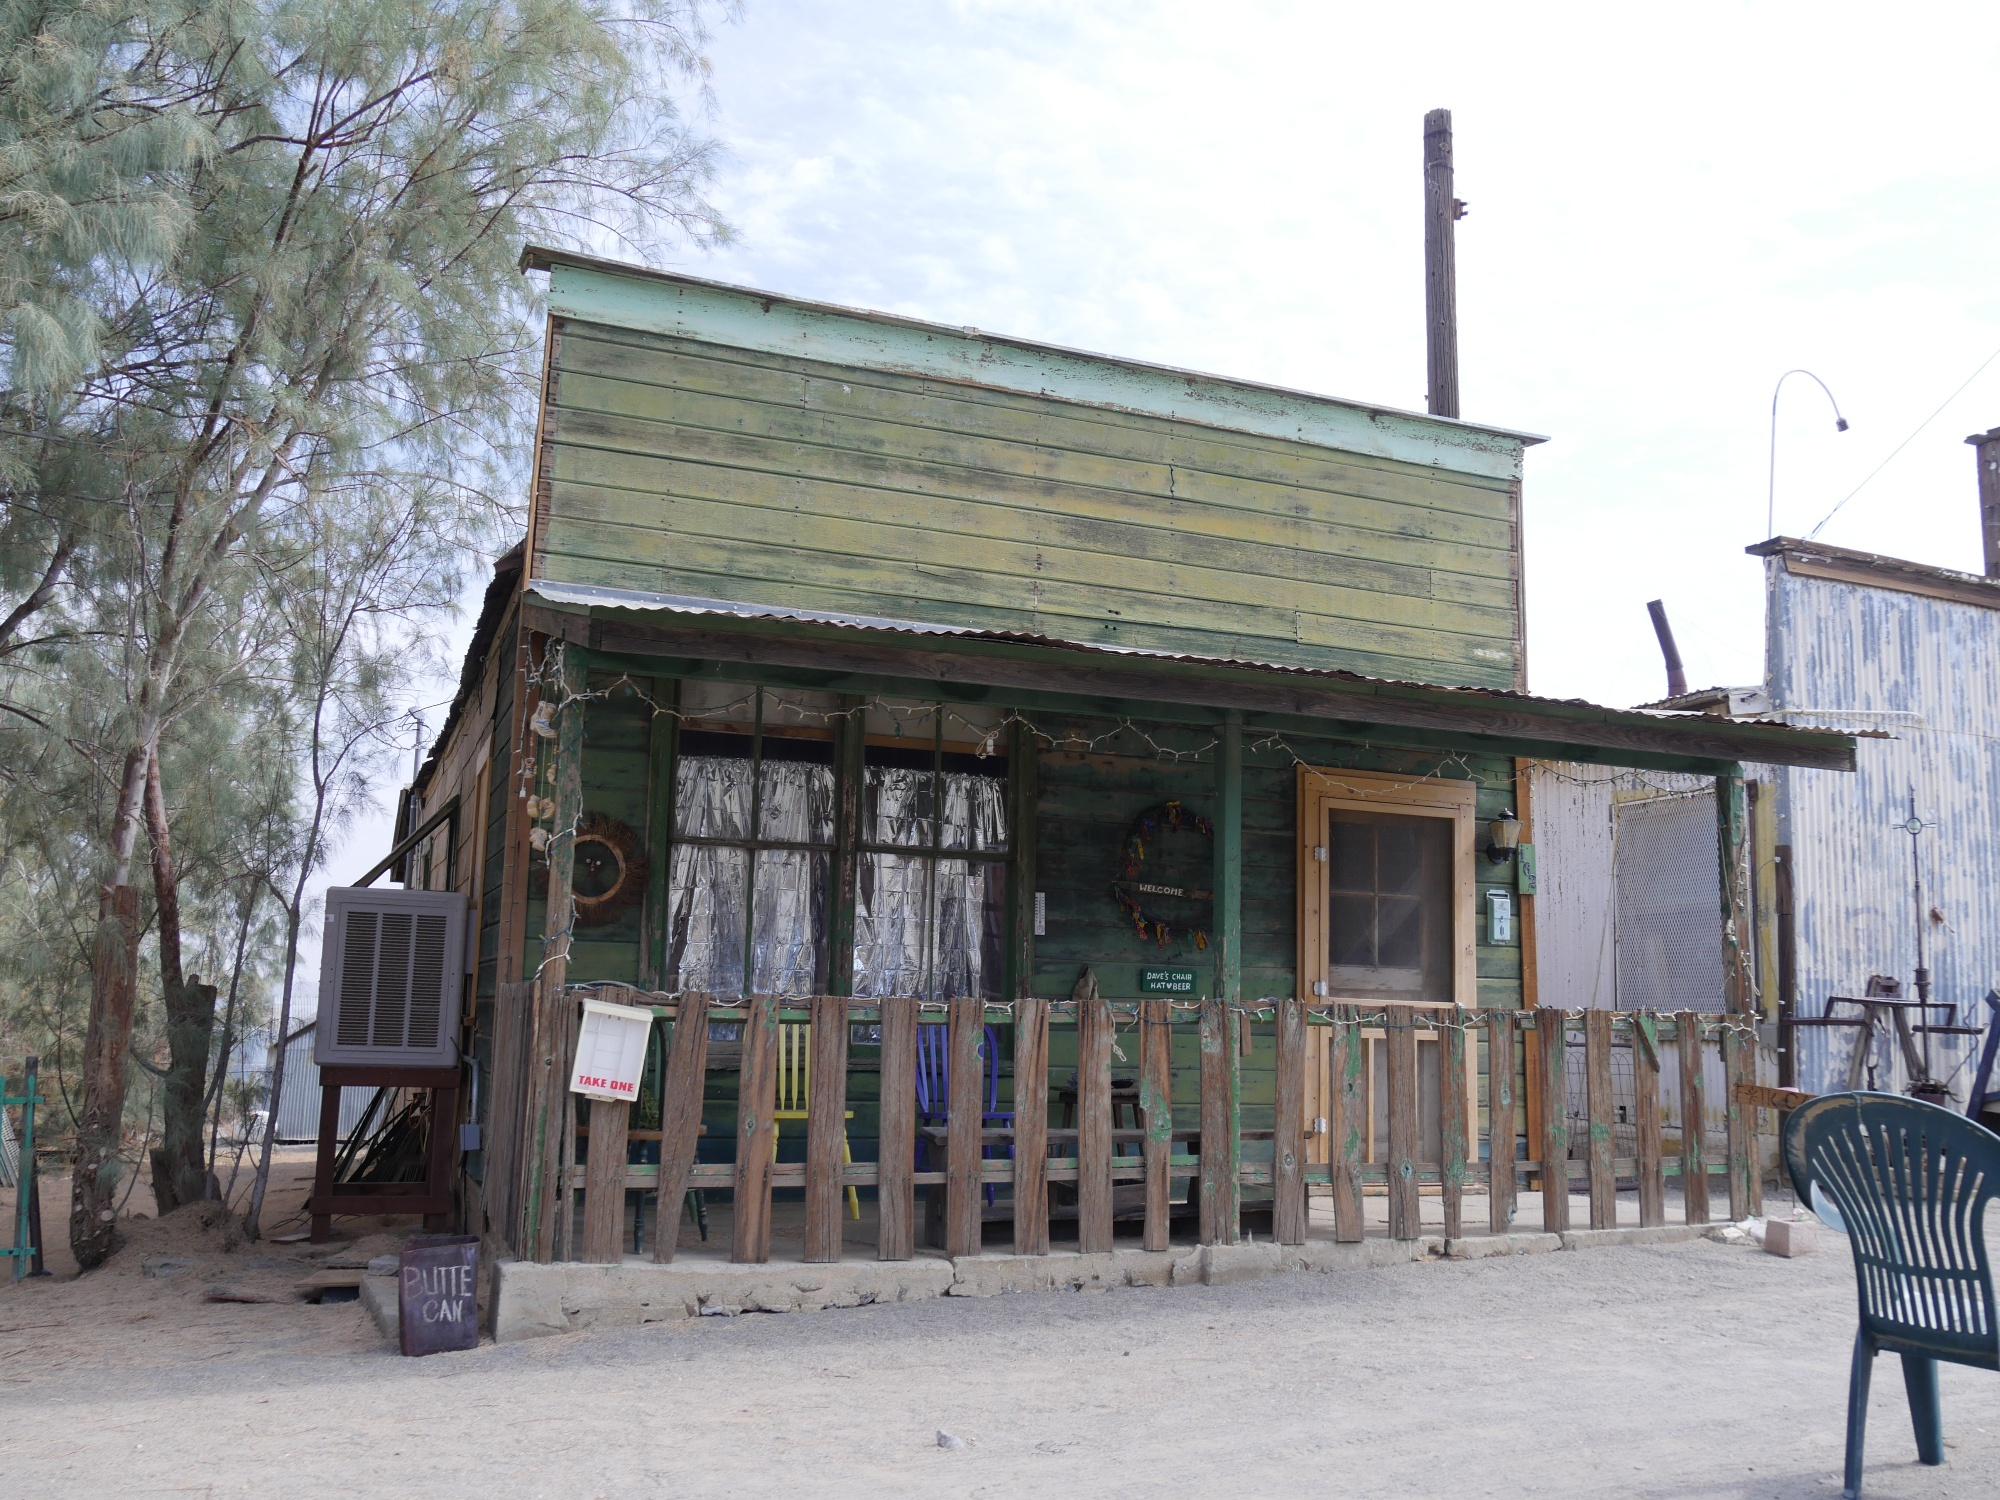Create a detailed backstory about the last occupant of the building. Our story begins with an elderly man named Henry, a retired mechanic who decided to settle down in this quaint building off Route 66 after years of servicing travelers' vehicles. Henry poured his heart into the building, painting it green to remind himself of the fields where he grew up. He would sit on the porch chair every evening, sharing stories with passing drivers and giving directions. Over time, fewer travelers came by, and Henry found himself spending more time alone. He left behind his tools neatly stored, a sign of his meticulous nature, and a collection of memorabilia from his years on the road. The Route 66 sign is a testament to his life’s journey, now quietly standing guard over his cherished memories. 